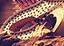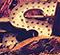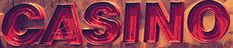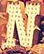What words can you see in these images in sequence, separated by a semicolon? #; S; CASINO; N 